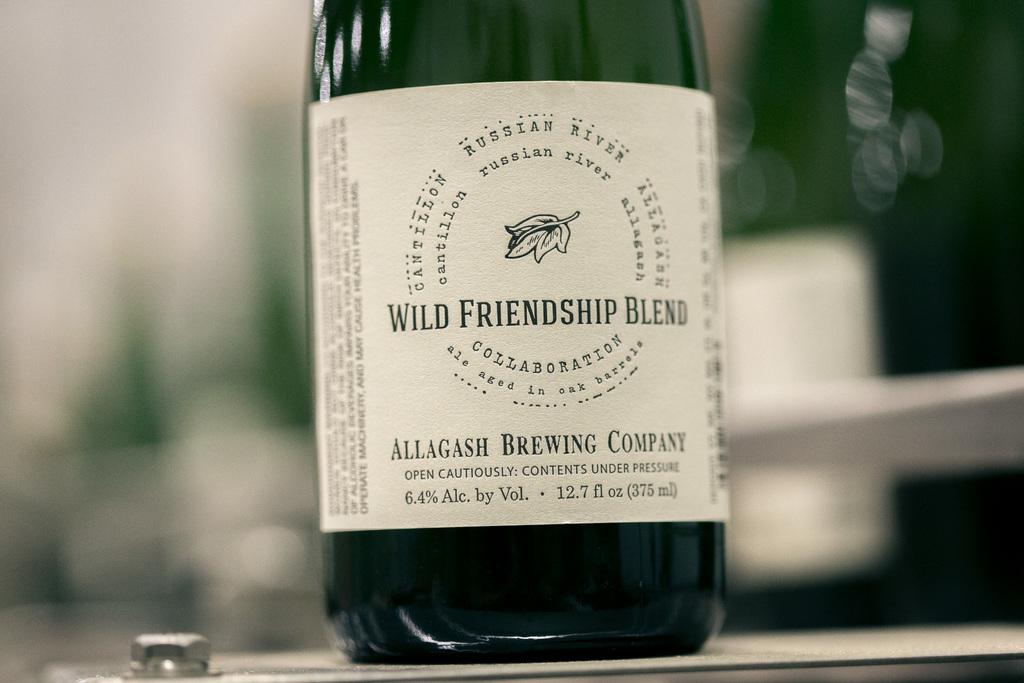What brewing company made this?
Give a very brief answer. Allagash. What type of brewing is it?
Make the answer very short. Allagash. 